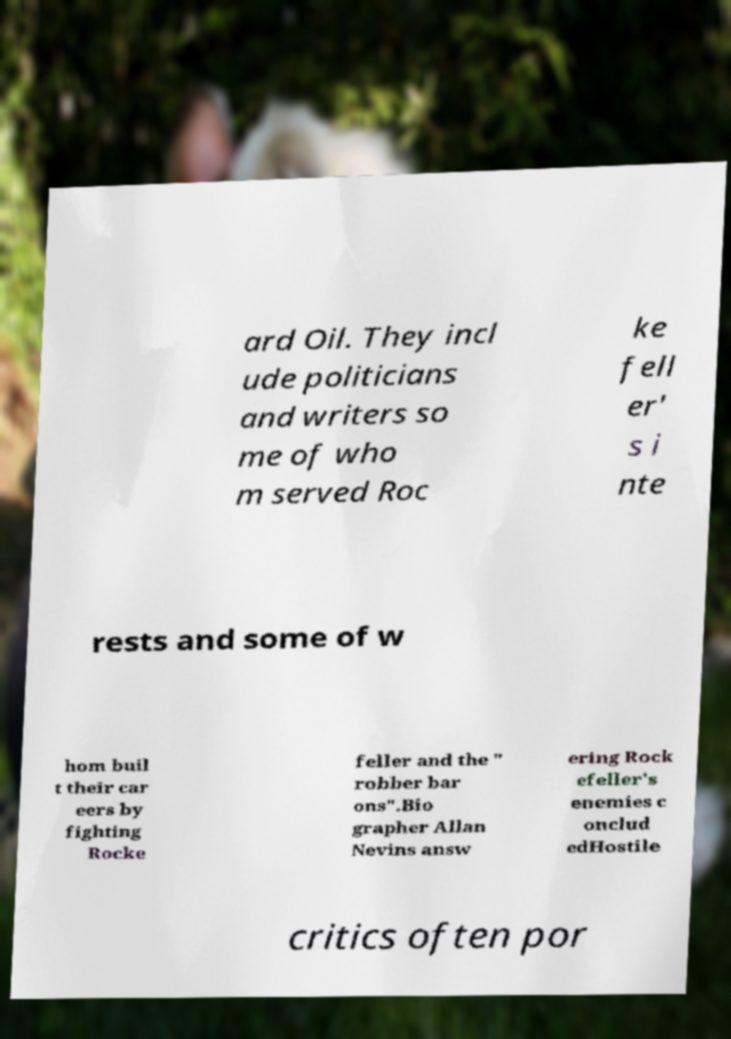I need the written content from this picture converted into text. Can you do that? ard Oil. They incl ude politicians and writers so me of who m served Roc ke fell er' s i nte rests and some of w hom buil t their car eers by fighting Rocke feller and the " robber bar ons".Bio grapher Allan Nevins answ ering Rock efeller's enemies c onclud edHostile critics often por 